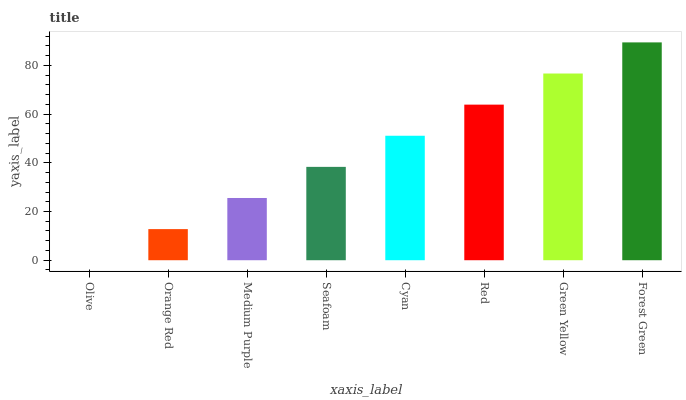Is Olive the minimum?
Answer yes or no. Yes. Is Forest Green the maximum?
Answer yes or no. Yes. Is Orange Red the minimum?
Answer yes or no. No. Is Orange Red the maximum?
Answer yes or no. No. Is Orange Red greater than Olive?
Answer yes or no. Yes. Is Olive less than Orange Red?
Answer yes or no. Yes. Is Olive greater than Orange Red?
Answer yes or no. No. Is Orange Red less than Olive?
Answer yes or no. No. Is Cyan the high median?
Answer yes or no. Yes. Is Seafoam the low median?
Answer yes or no. Yes. Is Green Yellow the high median?
Answer yes or no. No. Is Orange Red the low median?
Answer yes or no. No. 